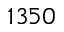Convert formula to latex. <formula><loc_0><loc_0><loc_500><loc_500>1 3 5 0</formula> 